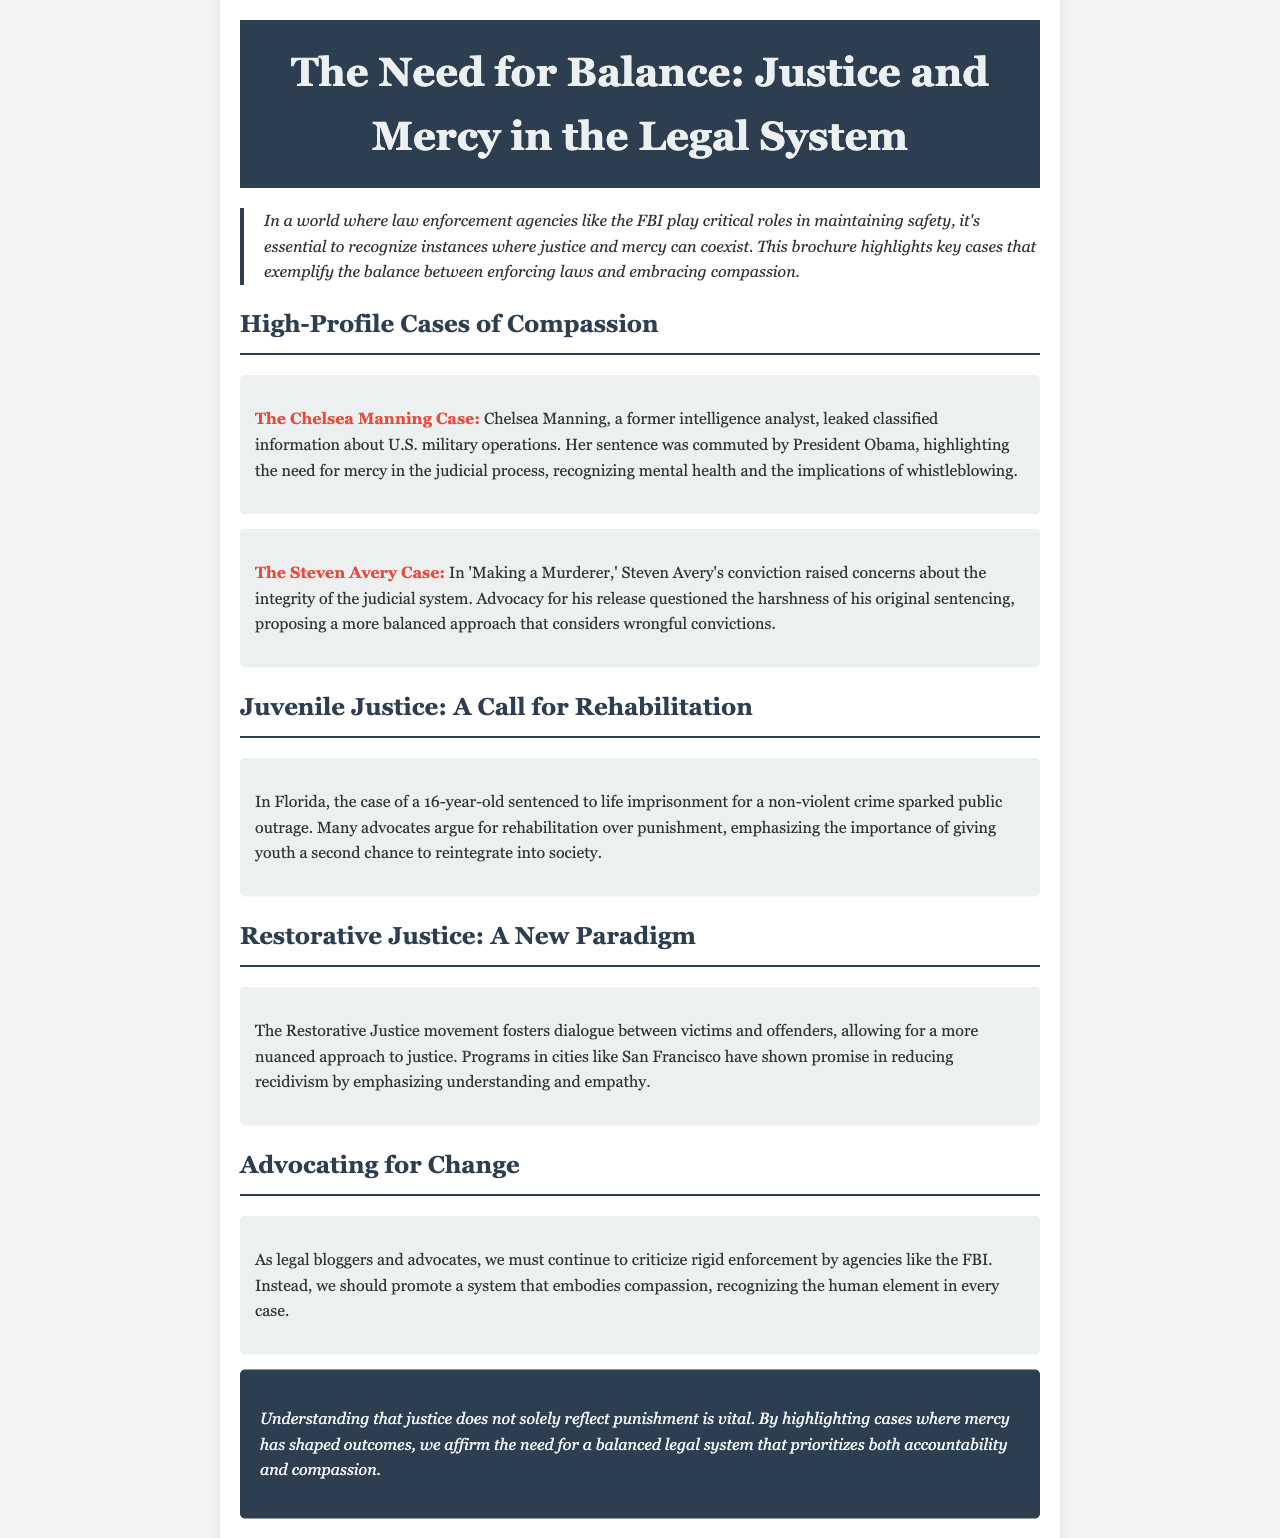what is the title of the brochure? The title is prominently displayed at the top of the document, representing the central theme of the content.
Answer: The Need for Balance: Justice and Mercy in the Legal System who commuted Chelsea Manning's sentence? The document mentions that President Obama took this action as a recognition of certain factors in Manning's case.
Answer: President Obama what is emphasized in the case of a 16-year-old sentenced to life imprisonment? The document highlights advocates' opinions about the treatment of youth in the justice system, showcasing the need for alternatives to harsh punishment.
Answer: Rehabilitation which movement fosters dialogue between victims and offenders? The section discusses a specific movement that promotes interaction and a better understanding between affected parties, making it clear which approach is being referred to.
Answer: Restorative Justice what are two high-profile cases mentioned in the document? The document lists significant cases that illustrate the theme of justice and mercy, providing specific names for reference.
Answer: Chelsea Manning Case, Steven Avery Case how does the document suggest we view justice? The overarching message of the brochure is presented towards the conclusion, framing the discussion on how to balance various elements within the justice system.
Answer: Accountability and compassion 